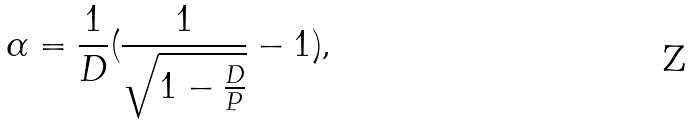Convert formula to latex. <formula><loc_0><loc_0><loc_500><loc_500>\alpha = \frac { 1 } { D } ( \frac { 1 } { \sqrt { 1 - \frac { D } { P } } } - 1 ) \text {,}</formula> 